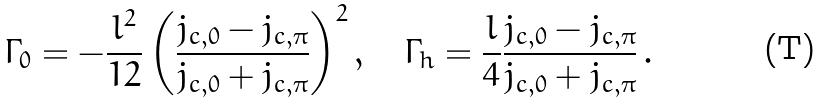Convert formula to latex. <formula><loc_0><loc_0><loc_500><loc_500>\Gamma _ { 0 } = - \frac { l ^ { 2 } } { 1 2 } \left ( \frac { j _ { c , 0 } - j _ { c , \pi } } { j _ { c , 0 } + j _ { c , \pi } } \right ) ^ { 2 } , \quad \Gamma _ { h } = \frac { l } { 4 } \frac { j _ { c , 0 } - j _ { c , \pi } } { j _ { c , 0 } + j _ { c , \pi } } \, .</formula> 